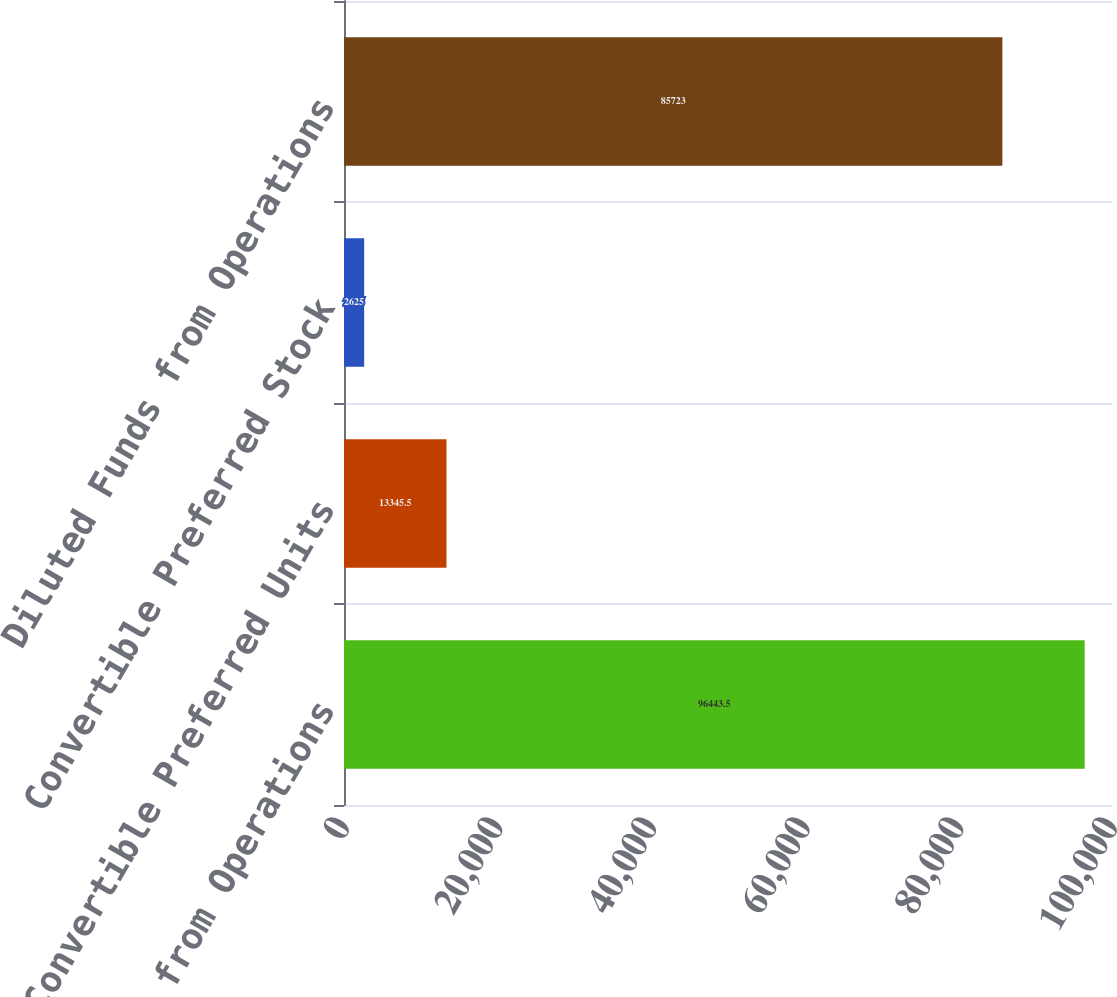Convert chart to OTSL. <chart><loc_0><loc_0><loc_500><loc_500><bar_chart><fcel>Basic Funds from Operations<fcel>Convertible Preferred Units<fcel>Convertible Preferred Stock<fcel>Diluted Funds from Operations<nl><fcel>96443.5<fcel>13345.5<fcel>2625<fcel>85723<nl></chart> 